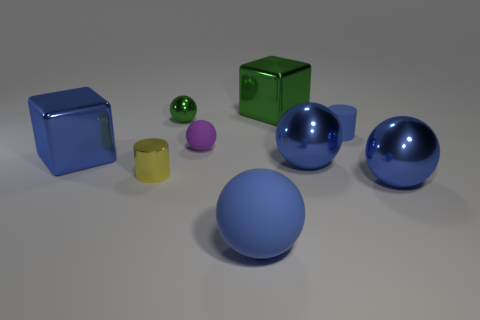What number of other objects are the same size as the blue matte ball?
Ensure brevity in your answer.  4. How many big objects are both left of the big green metal block and behind the yellow metal cylinder?
Make the answer very short. 1. Are there the same number of purple rubber objects right of the tiny purple matte ball and tiny purple balls that are left of the yellow metal object?
Provide a succinct answer. Yes. There is a blue metallic thing in front of the small yellow shiny cylinder; is it the same shape as the yellow shiny thing?
Make the answer very short. No. The tiny metal object that is behind the block that is left of the big matte sphere to the right of the small green metallic object is what shape?
Make the answer very short. Sphere. The small matte thing that is the same color as the big matte ball is what shape?
Provide a short and direct response. Cylinder. There is a big thing that is both on the left side of the large green thing and on the right side of the green sphere; what is its material?
Keep it short and to the point. Rubber. Is the number of large yellow metal blocks less than the number of large rubber objects?
Provide a short and direct response. Yes. There is a tiny purple matte object; is it the same shape as the blue matte thing that is behind the small purple ball?
Your answer should be very brief. No. There is a cylinder right of the green cube; is it the same size as the large matte ball?
Offer a terse response. No. 